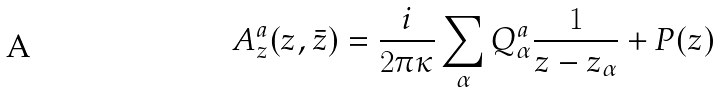<formula> <loc_0><loc_0><loc_500><loc_500>A _ { z } ^ { a } ( z , \bar { z } ) = { \frac { i } { 2 \pi \kappa } } \sum _ { \alpha } Q _ { \alpha } ^ { a } { \frac { 1 } { z - z _ { \alpha } } } + P ( z )</formula> 